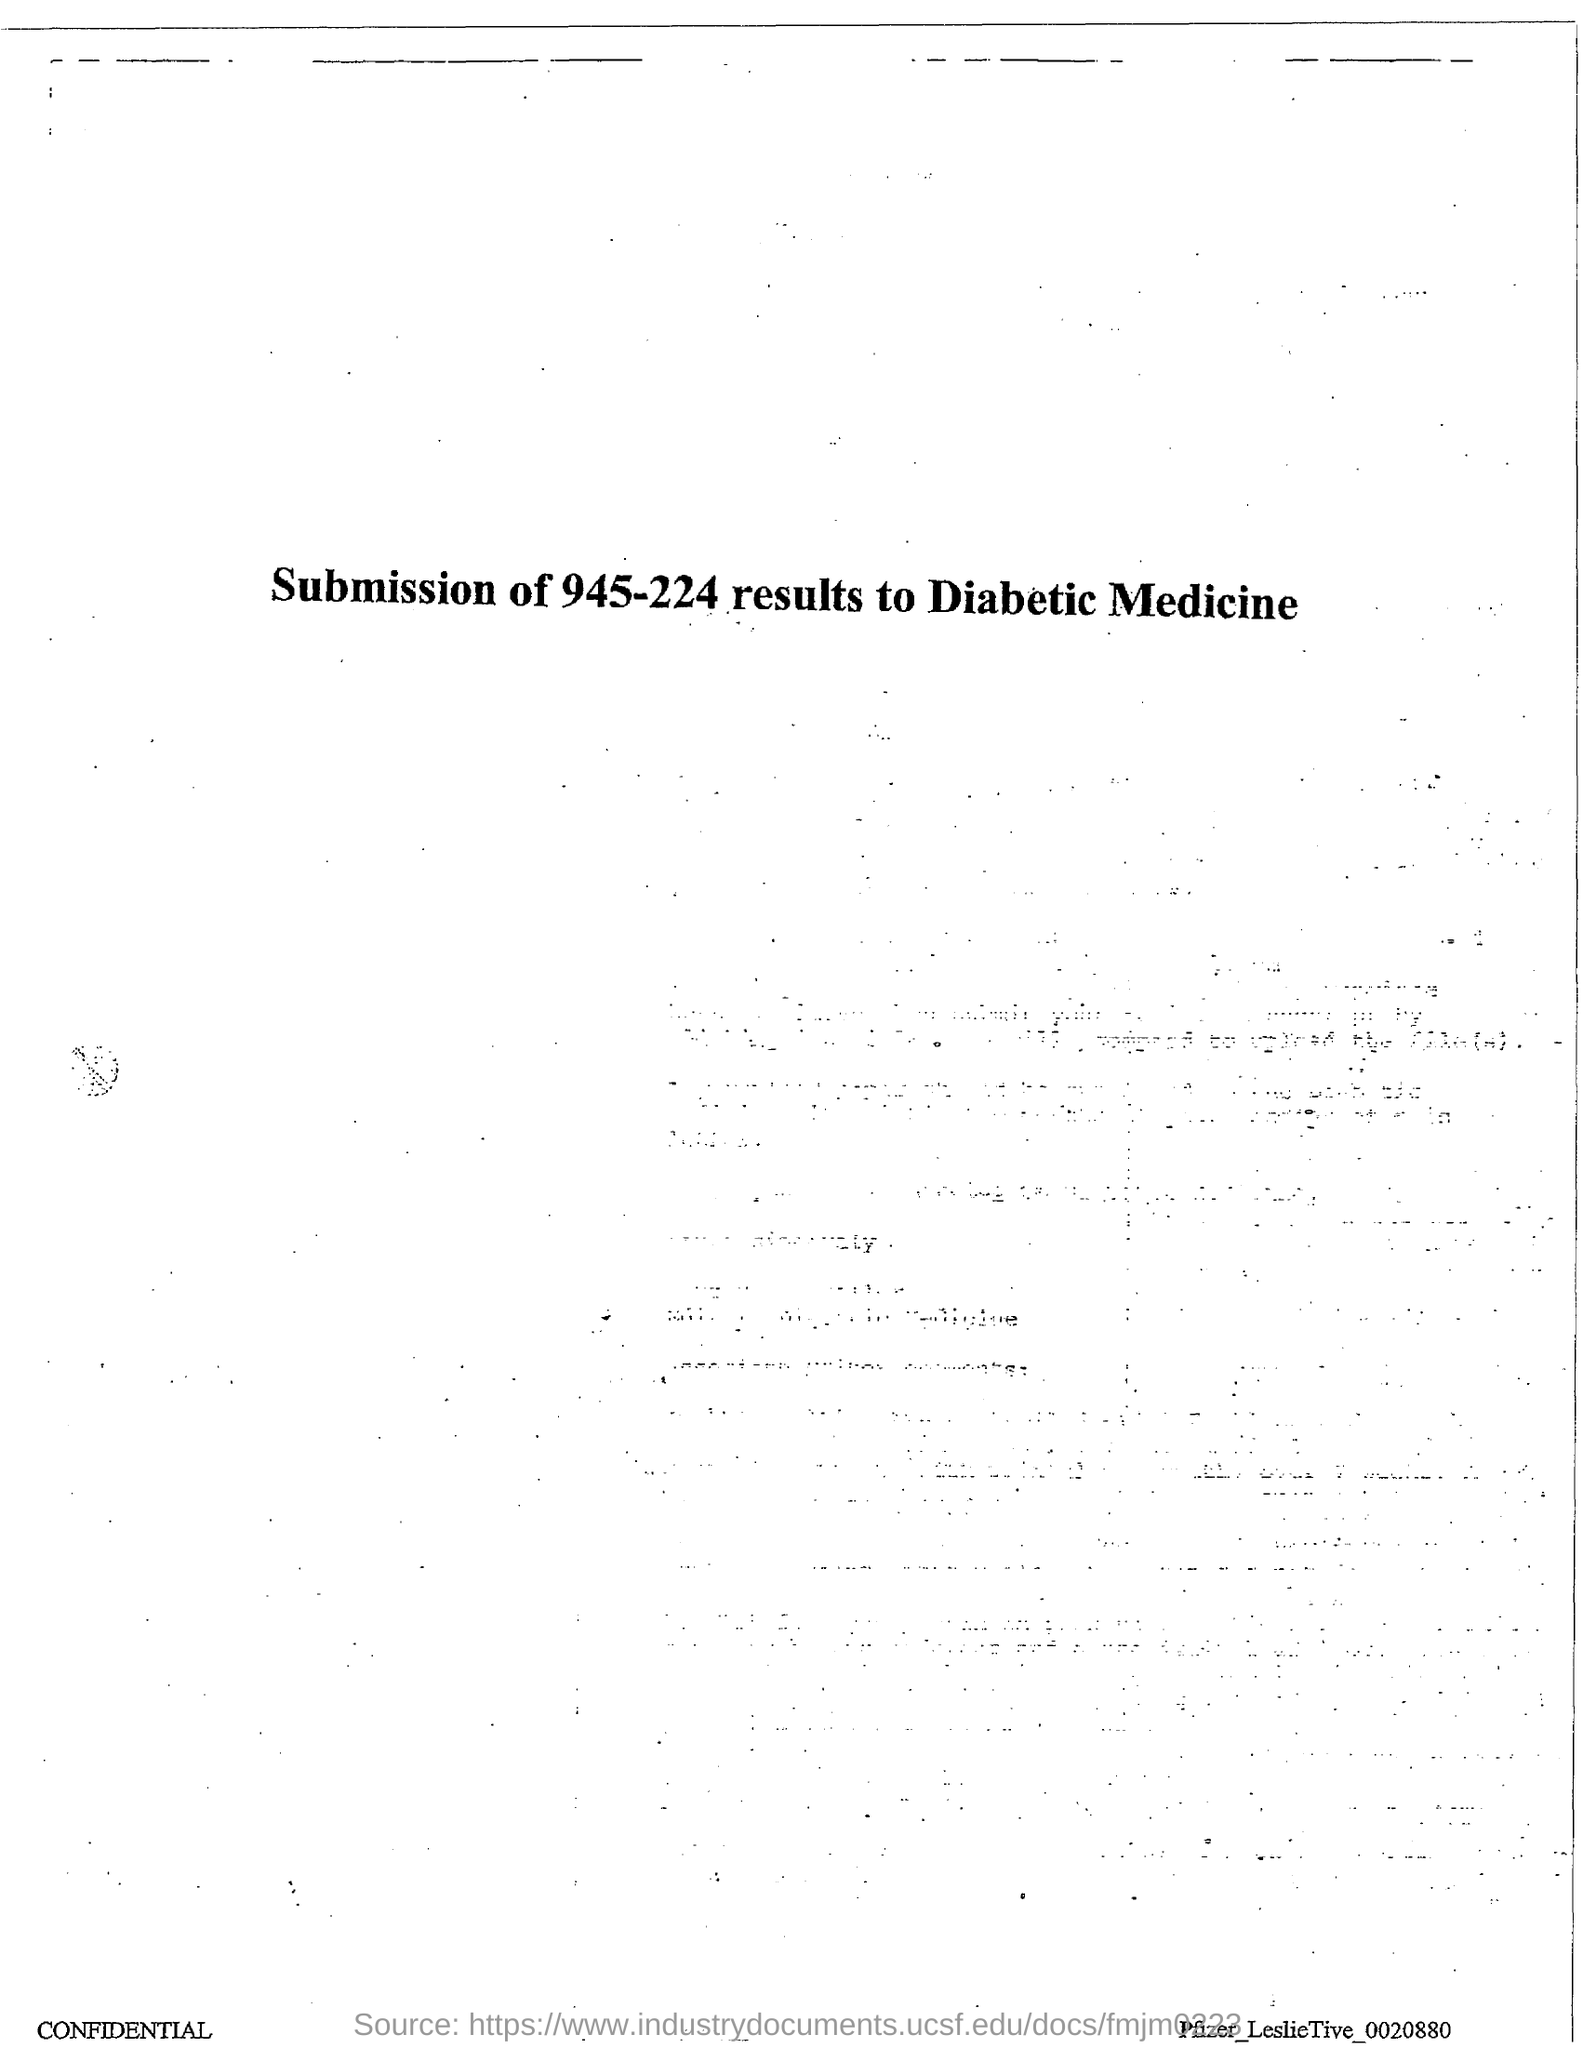List a handful of essential elements in this visual. The document in question is titled 'SUBMISSION OF 945-224 RESULTS TO DIABETIC MEDICINE.' 